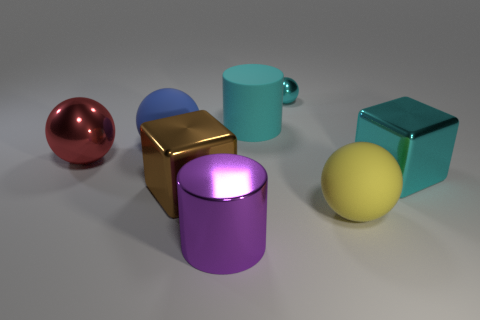There is a red metal thing that is the same shape as the large yellow rubber thing; what size is it?
Your answer should be compact. Large. The metallic ball that is the same color as the large rubber cylinder is what size?
Provide a succinct answer. Small. What number of blocks are yellow objects or big objects?
Provide a succinct answer. 2. Does the thing that is in front of the yellow sphere have the same shape as the tiny thing?
Your answer should be compact. No. Are there more big blue balls that are behind the big yellow sphere than big yellow rubber cylinders?
Make the answer very short. Yes. There is a metal ball that is the same size as the cyan matte thing; what is its color?
Give a very brief answer. Red. What number of things are either blue things on the right side of the red object or purple shiny cylinders?
Provide a short and direct response. 2. The large metallic thing that is the same color as the tiny thing is what shape?
Your response must be concise. Cube. What is the material of the yellow sphere that is on the right side of the big metallic block left of the small thing?
Make the answer very short. Rubber. Is there a cylinder that has the same material as the yellow ball?
Ensure brevity in your answer.  Yes. 